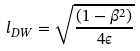Convert formula to latex. <formula><loc_0><loc_0><loc_500><loc_500>l _ { D W } = \sqrt { \frac { ( 1 - \beta ^ { 2 } ) } { 4 \epsilon } }</formula> 